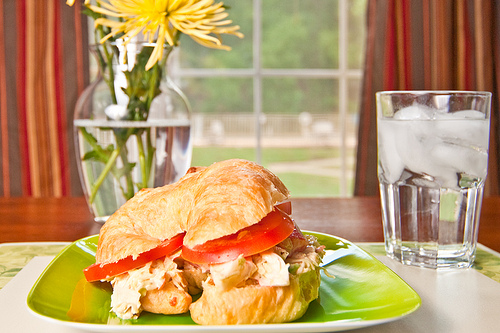What is the water in? The water is in a clear glass. 